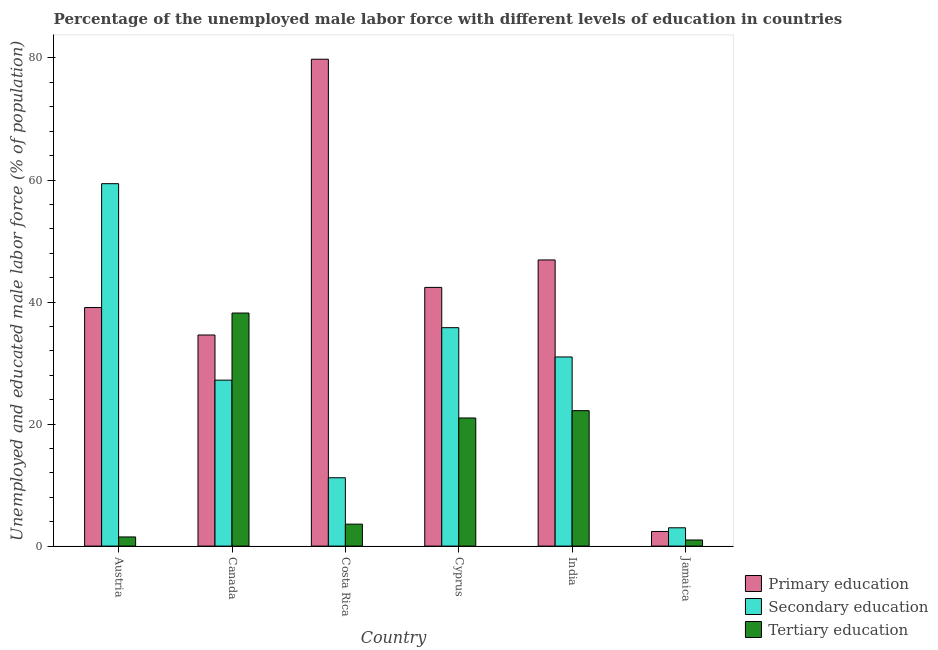How many different coloured bars are there?
Keep it short and to the point. 3. Are the number of bars per tick equal to the number of legend labels?
Make the answer very short. Yes. Are the number of bars on each tick of the X-axis equal?
Offer a terse response. Yes. What is the label of the 3rd group of bars from the left?
Provide a short and direct response. Costa Rica. What is the percentage of male labor force who received primary education in Austria?
Your answer should be very brief. 39.1. Across all countries, what is the maximum percentage of male labor force who received primary education?
Ensure brevity in your answer.  79.8. Across all countries, what is the minimum percentage of male labor force who received tertiary education?
Give a very brief answer. 1. In which country was the percentage of male labor force who received primary education minimum?
Your answer should be very brief. Jamaica. What is the total percentage of male labor force who received primary education in the graph?
Offer a very short reply. 245.2. What is the difference between the percentage of male labor force who received primary education in Cyprus and that in India?
Offer a very short reply. -4.5. What is the difference between the percentage of male labor force who received primary education in Canada and the percentage of male labor force who received tertiary education in Austria?
Your answer should be compact. 33.1. What is the average percentage of male labor force who received tertiary education per country?
Your response must be concise. 14.58. What is the difference between the percentage of male labor force who received primary education and percentage of male labor force who received tertiary education in Costa Rica?
Give a very brief answer. 76.2. What is the ratio of the percentage of male labor force who received primary education in India to that in Jamaica?
Your answer should be compact. 19.54. Is the difference between the percentage of male labor force who received primary education in Austria and Costa Rica greater than the difference between the percentage of male labor force who received secondary education in Austria and Costa Rica?
Provide a short and direct response. No. What is the difference between the highest and the second highest percentage of male labor force who received secondary education?
Your answer should be compact. 23.6. What is the difference between the highest and the lowest percentage of male labor force who received secondary education?
Offer a very short reply. 56.4. What does the 2nd bar from the left in Austria represents?
Your answer should be very brief. Secondary education. What does the 1st bar from the right in Costa Rica represents?
Your answer should be compact. Tertiary education. Is it the case that in every country, the sum of the percentage of male labor force who received primary education and percentage of male labor force who received secondary education is greater than the percentage of male labor force who received tertiary education?
Ensure brevity in your answer.  Yes. How many bars are there?
Ensure brevity in your answer.  18. Are all the bars in the graph horizontal?
Ensure brevity in your answer.  No. How many countries are there in the graph?
Keep it short and to the point. 6. Are the values on the major ticks of Y-axis written in scientific E-notation?
Provide a short and direct response. No. Does the graph contain any zero values?
Offer a very short reply. No. Does the graph contain grids?
Your answer should be very brief. No. What is the title of the graph?
Ensure brevity in your answer.  Percentage of the unemployed male labor force with different levels of education in countries. What is the label or title of the X-axis?
Your answer should be compact. Country. What is the label or title of the Y-axis?
Ensure brevity in your answer.  Unemployed and educated male labor force (% of population). What is the Unemployed and educated male labor force (% of population) in Primary education in Austria?
Your response must be concise. 39.1. What is the Unemployed and educated male labor force (% of population) of Secondary education in Austria?
Give a very brief answer. 59.4. What is the Unemployed and educated male labor force (% of population) of Primary education in Canada?
Make the answer very short. 34.6. What is the Unemployed and educated male labor force (% of population) in Secondary education in Canada?
Provide a succinct answer. 27.2. What is the Unemployed and educated male labor force (% of population) of Tertiary education in Canada?
Offer a terse response. 38.2. What is the Unemployed and educated male labor force (% of population) in Primary education in Costa Rica?
Your response must be concise. 79.8. What is the Unemployed and educated male labor force (% of population) of Secondary education in Costa Rica?
Provide a short and direct response. 11.2. What is the Unemployed and educated male labor force (% of population) in Tertiary education in Costa Rica?
Your answer should be compact. 3.6. What is the Unemployed and educated male labor force (% of population) of Primary education in Cyprus?
Keep it short and to the point. 42.4. What is the Unemployed and educated male labor force (% of population) in Secondary education in Cyprus?
Your answer should be compact. 35.8. What is the Unemployed and educated male labor force (% of population) in Tertiary education in Cyprus?
Make the answer very short. 21. What is the Unemployed and educated male labor force (% of population) in Primary education in India?
Provide a succinct answer. 46.9. What is the Unemployed and educated male labor force (% of population) of Secondary education in India?
Your answer should be very brief. 31. What is the Unemployed and educated male labor force (% of population) of Tertiary education in India?
Provide a succinct answer. 22.2. What is the Unemployed and educated male labor force (% of population) of Primary education in Jamaica?
Your answer should be compact. 2.4. Across all countries, what is the maximum Unemployed and educated male labor force (% of population) in Primary education?
Your response must be concise. 79.8. Across all countries, what is the maximum Unemployed and educated male labor force (% of population) in Secondary education?
Provide a short and direct response. 59.4. Across all countries, what is the maximum Unemployed and educated male labor force (% of population) of Tertiary education?
Keep it short and to the point. 38.2. Across all countries, what is the minimum Unemployed and educated male labor force (% of population) in Primary education?
Give a very brief answer. 2.4. Across all countries, what is the minimum Unemployed and educated male labor force (% of population) in Tertiary education?
Your response must be concise. 1. What is the total Unemployed and educated male labor force (% of population) in Primary education in the graph?
Your response must be concise. 245.2. What is the total Unemployed and educated male labor force (% of population) of Secondary education in the graph?
Your answer should be compact. 167.6. What is the total Unemployed and educated male labor force (% of population) in Tertiary education in the graph?
Offer a very short reply. 87.5. What is the difference between the Unemployed and educated male labor force (% of population) in Primary education in Austria and that in Canada?
Ensure brevity in your answer.  4.5. What is the difference between the Unemployed and educated male labor force (% of population) of Secondary education in Austria and that in Canada?
Offer a very short reply. 32.2. What is the difference between the Unemployed and educated male labor force (% of population) in Tertiary education in Austria and that in Canada?
Provide a short and direct response. -36.7. What is the difference between the Unemployed and educated male labor force (% of population) in Primary education in Austria and that in Costa Rica?
Provide a succinct answer. -40.7. What is the difference between the Unemployed and educated male labor force (% of population) of Secondary education in Austria and that in Costa Rica?
Your answer should be very brief. 48.2. What is the difference between the Unemployed and educated male labor force (% of population) in Secondary education in Austria and that in Cyprus?
Your response must be concise. 23.6. What is the difference between the Unemployed and educated male labor force (% of population) of Tertiary education in Austria and that in Cyprus?
Your response must be concise. -19.5. What is the difference between the Unemployed and educated male labor force (% of population) of Primary education in Austria and that in India?
Provide a short and direct response. -7.8. What is the difference between the Unemployed and educated male labor force (% of population) in Secondary education in Austria and that in India?
Provide a succinct answer. 28.4. What is the difference between the Unemployed and educated male labor force (% of population) in Tertiary education in Austria and that in India?
Provide a short and direct response. -20.7. What is the difference between the Unemployed and educated male labor force (% of population) of Primary education in Austria and that in Jamaica?
Your response must be concise. 36.7. What is the difference between the Unemployed and educated male labor force (% of population) of Secondary education in Austria and that in Jamaica?
Provide a succinct answer. 56.4. What is the difference between the Unemployed and educated male labor force (% of population) in Tertiary education in Austria and that in Jamaica?
Provide a short and direct response. 0.5. What is the difference between the Unemployed and educated male labor force (% of population) of Primary education in Canada and that in Costa Rica?
Ensure brevity in your answer.  -45.2. What is the difference between the Unemployed and educated male labor force (% of population) of Tertiary education in Canada and that in Costa Rica?
Give a very brief answer. 34.6. What is the difference between the Unemployed and educated male labor force (% of population) of Primary education in Canada and that in Cyprus?
Offer a terse response. -7.8. What is the difference between the Unemployed and educated male labor force (% of population) in Secondary education in Canada and that in Cyprus?
Offer a very short reply. -8.6. What is the difference between the Unemployed and educated male labor force (% of population) in Primary education in Canada and that in India?
Give a very brief answer. -12.3. What is the difference between the Unemployed and educated male labor force (% of population) in Primary education in Canada and that in Jamaica?
Offer a terse response. 32.2. What is the difference between the Unemployed and educated male labor force (% of population) in Secondary education in Canada and that in Jamaica?
Your answer should be compact. 24.2. What is the difference between the Unemployed and educated male labor force (% of population) of Tertiary education in Canada and that in Jamaica?
Provide a succinct answer. 37.2. What is the difference between the Unemployed and educated male labor force (% of population) of Primary education in Costa Rica and that in Cyprus?
Keep it short and to the point. 37.4. What is the difference between the Unemployed and educated male labor force (% of population) in Secondary education in Costa Rica and that in Cyprus?
Keep it short and to the point. -24.6. What is the difference between the Unemployed and educated male labor force (% of population) in Tertiary education in Costa Rica and that in Cyprus?
Your answer should be compact. -17.4. What is the difference between the Unemployed and educated male labor force (% of population) of Primary education in Costa Rica and that in India?
Your response must be concise. 32.9. What is the difference between the Unemployed and educated male labor force (% of population) of Secondary education in Costa Rica and that in India?
Your response must be concise. -19.8. What is the difference between the Unemployed and educated male labor force (% of population) in Tertiary education in Costa Rica and that in India?
Your answer should be compact. -18.6. What is the difference between the Unemployed and educated male labor force (% of population) of Primary education in Costa Rica and that in Jamaica?
Offer a very short reply. 77.4. What is the difference between the Unemployed and educated male labor force (% of population) of Secondary education in Costa Rica and that in Jamaica?
Give a very brief answer. 8.2. What is the difference between the Unemployed and educated male labor force (% of population) in Tertiary education in Costa Rica and that in Jamaica?
Your answer should be very brief. 2.6. What is the difference between the Unemployed and educated male labor force (% of population) in Primary education in Cyprus and that in India?
Your response must be concise. -4.5. What is the difference between the Unemployed and educated male labor force (% of population) in Primary education in Cyprus and that in Jamaica?
Ensure brevity in your answer.  40. What is the difference between the Unemployed and educated male labor force (% of population) in Secondary education in Cyprus and that in Jamaica?
Provide a short and direct response. 32.8. What is the difference between the Unemployed and educated male labor force (% of population) of Tertiary education in Cyprus and that in Jamaica?
Provide a succinct answer. 20. What is the difference between the Unemployed and educated male labor force (% of population) of Primary education in India and that in Jamaica?
Give a very brief answer. 44.5. What is the difference between the Unemployed and educated male labor force (% of population) in Tertiary education in India and that in Jamaica?
Give a very brief answer. 21.2. What is the difference between the Unemployed and educated male labor force (% of population) of Primary education in Austria and the Unemployed and educated male labor force (% of population) of Tertiary education in Canada?
Your answer should be compact. 0.9. What is the difference between the Unemployed and educated male labor force (% of population) in Secondary education in Austria and the Unemployed and educated male labor force (% of population) in Tertiary education in Canada?
Your answer should be very brief. 21.2. What is the difference between the Unemployed and educated male labor force (% of population) of Primary education in Austria and the Unemployed and educated male labor force (% of population) of Secondary education in Costa Rica?
Ensure brevity in your answer.  27.9. What is the difference between the Unemployed and educated male labor force (% of population) in Primary education in Austria and the Unemployed and educated male labor force (% of population) in Tertiary education in Costa Rica?
Your answer should be compact. 35.5. What is the difference between the Unemployed and educated male labor force (% of population) in Secondary education in Austria and the Unemployed and educated male labor force (% of population) in Tertiary education in Costa Rica?
Make the answer very short. 55.8. What is the difference between the Unemployed and educated male labor force (% of population) in Secondary education in Austria and the Unemployed and educated male labor force (% of population) in Tertiary education in Cyprus?
Keep it short and to the point. 38.4. What is the difference between the Unemployed and educated male labor force (% of population) in Secondary education in Austria and the Unemployed and educated male labor force (% of population) in Tertiary education in India?
Give a very brief answer. 37.2. What is the difference between the Unemployed and educated male labor force (% of population) in Primary education in Austria and the Unemployed and educated male labor force (% of population) in Secondary education in Jamaica?
Provide a short and direct response. 36.1. What is the difference between the Unemployed and educated male labor force (% of population) in Primary education in Austria and the Unemployed and educated male labor force (% of population) in Tertiary education in Jamaica?
Your response must be concise. 38.1. What is the difference between the Unemployed and educated male labor force (% of population) of Secondary education in Austria and the Unemployed and educated male labor force (% of population) of Tertiary education in Jamaica?
Offer a terse response. 58.4. What is the difference between the Unemployed and educated male labor force (% of population) of Primary education in Canada and the Unemployed and educated male labor force (% of population) of Secondary education in Costa Rica?
Your answer should be compact. 23.4. What is the difference between the Unemployed and educated male labor force (% of population) in Secondary education in Canada and the Unemployed and educated male labor force (% of population) in Tertiary education in Costa Rica?
Your answer should be compact. 23.6. What is the difference between the Unemployed and educated male labor force (% of population) in Secondary education in Canada and the Unemployed and educated male labor force (% of population) in Tertiary education in Cyprus?
Make the answer very short. 6.2. What is the difference between the Unemployed and educated male labor force (% of population) in Primary education in Canada and the Unemployed and educated male labor force (% of population) in Secondary education in India?
Offer a very short reply. 3.6. What is the difference between the Unemployed and educated male labor force (% of population) of Secondary education in Canada and the Unemployed and educated male labor force (% of population) of Tertiary education in India?
Your answer should be compact. 5. What is the difference between the Unemployed and educated male labor force (% of population) in Primary education in Canada and the Unemployed and educated male labor force (% of population) in Secondary education in Jamaica?
Provide a short and direct response. 31.6. What is the difference between the Unemployed and educated male labor force (% of population) in Primary education in Canada and the Unemployed and educated male labor force (% of population) in Tertiary education in Jamaica?
Ensure brevity in your answer.  33.6. What is the difference between the Unemployed and educated male labor force (% of population) of Secondary education in Canada and the Unemployed and educated male labor force (% of population) of Tertiary education in Jamaica?
Keep it short and to the point. 26.2. What is the difference between the Unemployed and educated male labor force (% of population) in Primary education in Costa Rica and the Unemployed and educated male labor force (% of population) in Tertiary education in Cyprus?
Keep it short and to the point. 58.8. What is the difference between the Unemployed and educated male labor force (% of population) of Primary education in Costa Rica and the Unemployed and educated male labor force (% of population) of Secondary education in India?
Your response must be concise. 48.8. What is the difference between the Unemployed and educated male labor force (% of population) in Primary education in Costa Rica and the Unemployed and educated male labor force (% of population) in Tertiary education in India?
Provide a succinct answer. 57.6. What is the difference between the Unemployed and educated male labor force (% of population) in Primary education in Costa Rica and the Unemployed and educated male labor force (% of population) in Secondary education in Jamaica?
Keep it short and to the point. 76.8. What is the difference between the Unemployed and educated male labor force (% of population) of Primary education in Costa Rica and the Unemployed and educated male labor force (% of population) of Tertiary education in Jamaica?
Provide a succinct answer. 78.8. What is the difference between the Unemployed and educated male labor force (% of population) of Secondary education in Costa Rica and the Unemployed and educated male labor force (% of population) of Tertiary education in Jamaica?
Offer a terse response. 10.2. What is the difference between the Unemployed and educated male labor force (% of population) of Primary education in Cyprus and the Unemployed and educated male labor force (% of population) of Tertiary education in India?
Your answer should be compact. 20.2. What is the difference between the Unemployed and educated male labor force (% of population) of Secondary education in Cyprus and the Unemployed and educated male labor force (% of population) of Tertiary education in India?
Ensure brevity in your answer.  13.6. What is the difference between the Unemployed and educated male labor force (% of population) in Primary education in Cyprus and the Unemployed and educated male labor force (% of population) in Secondary education in Jamaica?
Offer a terse response. 39.4. What is the difference between the Unemployed and educated male labor force (% of population) in Primary education in Cyprus and the Unemployed and educated male labor force (% of population) in Tertiary education in Jamaica?
Your answer should be very brief. 41.4. What is the difference between the Unemployed and educated male labor force (% of population) in Secondary education in Cyprus and the Unemployed and educated male labor force (% of population) in Tertiary education in Jamaica?
Offer a terse response. 34.8. What is the difference between the Unemployed and educated male labor force (% of population) in Primary education in India and the Unemployed and educated male labor force (% of population) in Secondary education in Jamaica?
Your answer should be compact. 43.9. What is the difference between the Unemployed and educated male labor force (% of population) in Primary education in India and the Unemployed and educated male labor force (% of population) in Tertiary education in Jamaica?
Ensure brevity in your answer.  45.9. What is the average Unemployed and educated male labor force (% of population) of Primary education per country?
Offer a terse response. 40.87. What is the average Unemployed and educated male labor force (% of population) in Secondary education per country?
Provide a succinct answer. 27.93. What is the average Unemployed and educated male labor force (% of population) in Tertiary education per country?
Provide a succinct answer. 14.58. What is the difference between the Unemployed and educated male labor force (% of population) of Primary education and Unemployed and educated male labor force (% of population) of Secondary education in Austria?
Your answer should be compact. -20.3. What is the difference between the Unemployed and educated male labor force (% of population) in Primary education and Unemployed and educated male labor force (% of population) in Tertiary education in Austria?
Your answer should be very brief. 37.6. What is the difference between the Unemployed and educated male labor force (% of population) in Secondary education and Unemployed and educated male labor force (% of population) in Tertiary education in Austria?
Provide a short and direct response. 57.9. What is the difference between the Unemployed and educated male labor force (% of population) in Primary education and Unemployed and educated male labor force (% of population) in Tertiary education in Canada?
Provide a short and direct response. -3.6. What is the difference between the Unemployed and educated male labor force (% of population) of Secondary education and Unemployed and educated male labor force (% of population) of Tertiary education in Canada?
Offer a very short reply. -11. What is the difference between the Unemployed and educated male labor force (% of population) of Primary education and Unemployed and educated male labor force (% of population) of Secondary education in Costa Rica?
Your response must be concise. 68.6. What is the difference between the Unemployed and educated male labor force (% of population) in Primary education and Unemployed and educated male labor force (% of population) in Tertiary education in Costa Rica?
Ensure brevity in your answer.  76.2. What is the difference between the Unemployed and educated male labor force (% of population) in Secondary education and Unemployed and educated male labor force (% of population) in Tertiary education in Costa Rica?
Provide a short and direct response. 7.6. What is the difference between the Unemployed and educated male labor force (% of population) of Primary education and Unemployed and educated male labor force (% of population) of Tertiary education in Cyprus?
Offer a very short reply. 21.4. What is the difference between the Unemployed and educated male labor force (% of population) in Secondary education and Unemployed and educated male labor force (% of population) in Tertiary education in Cyprus?
Ensure brevity in your answer.  14.8. What is the difference between the Unemployed and educated male labor force (% of population) in Primary education and Unemployed and educated male labor force (% of population) in Tertiary education in India?
Ensure brevity in your answer.  24.7. What is the difference between the Unemployed and educated male labor force (% of population) of Secondary education and Unemployed and educated male labor force (% of population) of Tertiary education in India?
Keep it short and to the point. 8.8. What is the difference between the Unemployed and educated male labor force (% of population) of Primary education and Unemployed and educated male labor force (% of population) of Tertiary education in Jamaica?
Provide a short and direct response. 1.4. What is the ratio of the Unemployed and educated male labor force (% of population) of Primary education in Austria to that in Canada?
Make the answer very short. 1.13. What is the ratio of the Unemployed and educated male labor force (% of population) in Secondary education in Austria to that in Canada?
Make the answer very short. 2.18. What is the ratio of the Unemployed and educated male labor force (% of population) of Tertiary education in Austria to that in Canada?
Your response must be concise. 0.04. What is the ratio of the Unemployed and educated male labor force (% of population) of Primary education in Austria to that in Costa Rica?
Offer a terse response. 0.49. What is the ratio of the Unemployed and educated male labor force (% of population) of Secondary education in Austria to that in Costa Rica?
Give a very brief answer. 5.3. What is the ratio of the Unemployed and educated male labor force (% of population) of Tertiary education in Austria to that in Costa Rica?
Your answer should be very brief. 0.42. What is the ratio of the Unemployed and educated male labor force (% of population) in Primary education in Austria to that in Cyprus?
Give a very brief answer. 0.92. What is the ratio of the Unemployed and educated male labor force (% of population) of Secondary education in Austria to that in Cyprus?
Make the answer very short. 1.66. What is the ratio of the Unemployed and educated male labor force (% of population) in Tertiary education in Austria to that in Cyprus?
Provide a succinct answer. 0.07. What is the ratio of the Unemployed and educated male labor force (% of population) in Primary education in Austria to that in India?
Make the answer very short. 0.83. What is the ratio of the Unemployed and educated male labor force (% of population) of Secondary education in Austria to that in India?
Your response must be concise. 1.92. What is the ratio of the Unemployed and educated male labor force (% of population) of Tertiary education in Austria to that in India?
Keep it short and to the point. 0.07. What is the ratio of the Unemployed and educated male labor force (% of population) in Primary education in Austria to that in Jamaica?
Make the answer very short. 16.29. What is the ratio of the Unemployed and educated male labor force (% of population) of Secondary education in Austria to that in Jamaica?
Your response must be concise. 19.8. What is the ratio of the Unemployed and educated male labor force (% of population) of Tertiary education in Austria to that in Jamaica?
Give a very brief answer. 1.5. What is the ratio of the Unemployed and educated male labor force (% of population) in Primary education in Canada to that in Costa Rica?
Make the answer very short. 0.43. What is the ratio of the Unemployed and educated male labor force (% of population) of Secondary education in Canada to that in Costa Rica?
Your answer should be compact. 2.43. What is the ratio of the Unemployed and educated male labor force (% of population) in Tertiary education in Canada to that in Costa Rica?
Provide a short and direct response. 10.61. What is the ratio of the Unemployed and educated male labor force (% of population) of Primary education in Canada to that in Cyprus?
Your answer should be very brief. 0.82. What is the ratio of the Unemployed and educated male labor force (% of population) of Secondary education in Canada to that in Cyprus?
Provide a short and direct response. 0.76. What is the ratio of the Unemployed and educated male labor force (% of population) in Tertiary education in Canada to that in Cyprus?
Keep it short and to the point. 1.82. What is the ratio of the Unemployed and educated male labor force (% of population) in Primary education in Canada to that in India?
Keep it short and to the point. 0.74. What is the ratio of the Unemployed and educated male labor force (% of population) of Secondary education in Canada to that in India?
Your answer should be compact. 0.88. What is the ratio of the Unemployed and educated male labor force (% of population) of Tertiary education in Canada to that in India?
Keep it short and to the point. 1.72. What is the ratio of the Unemployed and educated male labor force (% of population) of Primary education in Canada to that in Jamaica?
Give a very brief answer. 14.42. What is the ratio of the Unemployed and educated male labor force (% of population) in Secondary education in Canada to that in Jamaica?
Give a very brief answer. 9.07. What is the ratio of the Unemployed and educated male labor force (% of population) in Tertiary education in Canada to that in Jamaica?
Offer a terse response. 38.2. What is the ratio of the Unemployed and educated male labor force (% of population) of Primary education in Costa Rica to that in Cyprus?
Offer a very short reply. 1.88. What is the ratio of the Unemployed and educated male labor force (% of population) of Secondary education in Costa Rica to that in Cyprus?
Ensure brevity in your answer.  0.31. What is the ratio of the Unemployed and educated male labor force (% of population) of Tertiary education in Costa Rica to that in Cyprus?
Your answer should be compact. 0.17. What is the ratio of the Unemployed and educated male labor force (% of population) of Primary education in Costa Rica to that in India?
Keep it short and to the point. 1.7. What is the ratio of the Unemployed and educated male labor force (% of population) in Secondary education in Costa Rica to that in India?
Ensure brevity in your answer.  0.36. What is the ratio of the Unemployed and educated male labor force (% of population) of Tertiary education in Costa Rica to that in India?
Provide a succinct answer. 0.16. What is the ratio of the Unemployed and educated male labor force (% of population) of Primary education in Costa Rica to that in Jamaica?
Make the answer very short. 33.25. What is the ratio of the Unemployed and educated male labor force (% of population) of Secondary education in Costa Rica to that in Jamaica?
Your answer should be very brief. 3.73. What is the ratio of the Unemployed and educated male labor force (% of population) of Primary education in Cyprus to that in India?
Provide a succinct answer. 0.9. What is the ratio of the Unemployed and educated male labor force (% of population) in Secondary education in Cyprus to that in India?
Give a very brief answer. 1.15. What is the ratio of the Unemployed and educated male labor force (% of population) in Tertiary education in Cyprus to that in India?
Your answer should be compact. 0.95. What is the ratio of the Unemployed and educated male labor force (% of population) of Primary education in Cyprus to that in Jamaica?
Provide a short and direct response. 17.67. What is the ratio of the Unemployed and educated male labor force (% of population) in Secondary education in Cyprus to that in Jamaica?
Provide a short and direct response. 11.93. What is the ratio of the Unemployed and educated male labor force (% of population) of Tertiary education in Cyprus to that in Jamaica?
Offer a very short reply. 21. What is the ratio of the Unemployed and educated male labor force (% of population) in Primary education in India to that in Jamaica?
Your answer should be compact. 19.54. What is the ratio of the Unemployed and educated male labor force (% of population) of Secondary education in India to that in Jamaica?
Offer a very short reply. 10.33. What is the difference between the highest and the second highest Unemployed and educated male labor force (% of population) of Primary education?
Make the answer very short. 32.9. What is the difference between the highest and the second highest Unemployed and educated male labor force (% of population) in Secondary education?
Ensure brevity in your answer.  23.6. What is the difference between the highest and the lowest Unemployed and educated male labor force (% of population) in Primary education?
Ensure brevity in your answer.  77.4. What is the difference between the highest and the lowest Unemployed and educated male labor force (% of population) in Secondary education?
Your answer should be compact. 56.4. What is the difference between the highest and the lowest Unemployed and educated male labor force (% of population) in Tertiary education?
Provide a succinct answer. 37.2. 